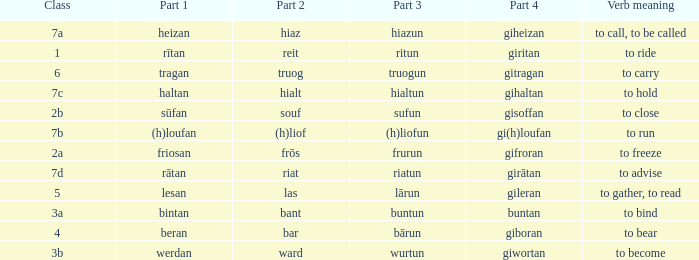What is the part 4 when part 1 is "lesan"? Gileran. 